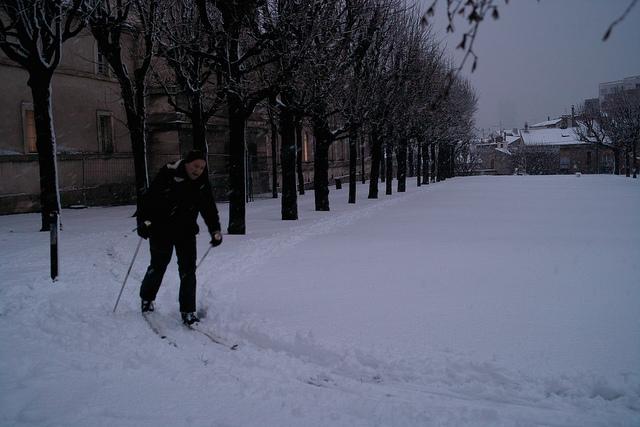Is he skiing?
Be succinct. Yes. What type of trees are present in this picture?
Give a very brief answer. Oak. How many dogs are there?
Keep it brief. 0. Is this a steep slope?
Answer briefly. No. 